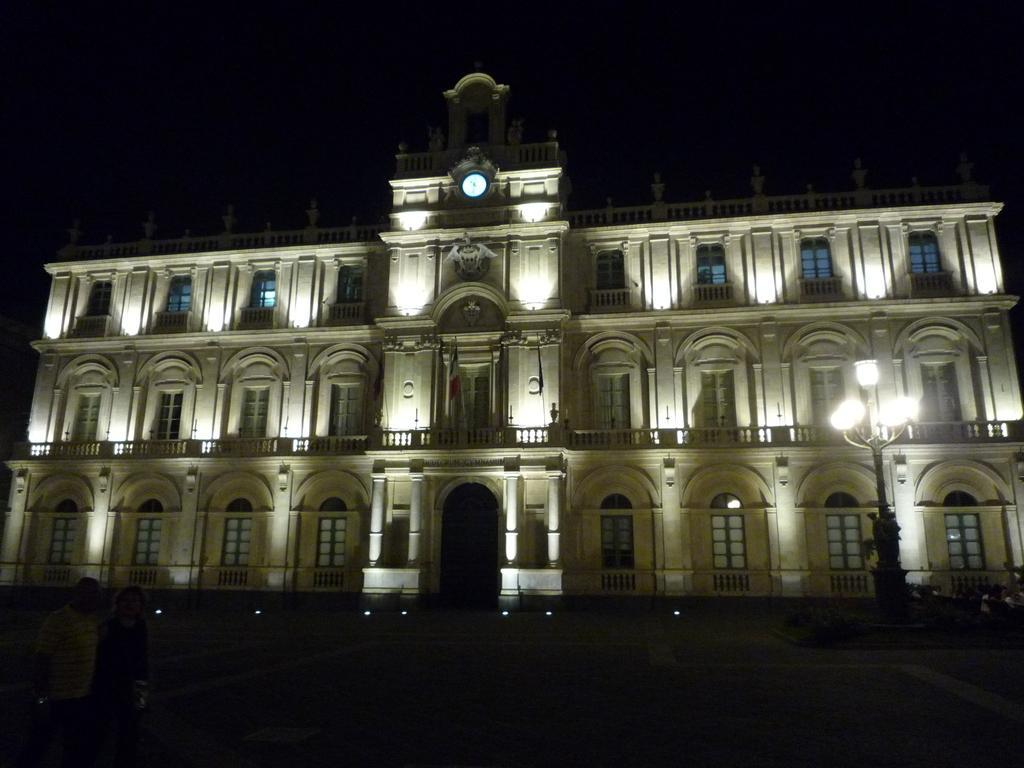Describe this image in one or two sentences. On the left side of the image there are two people on the road. Behind them there is a building. There are lights. There are windows. In the center of the image there is a clock on the wall. In the background of the image there is sky. 